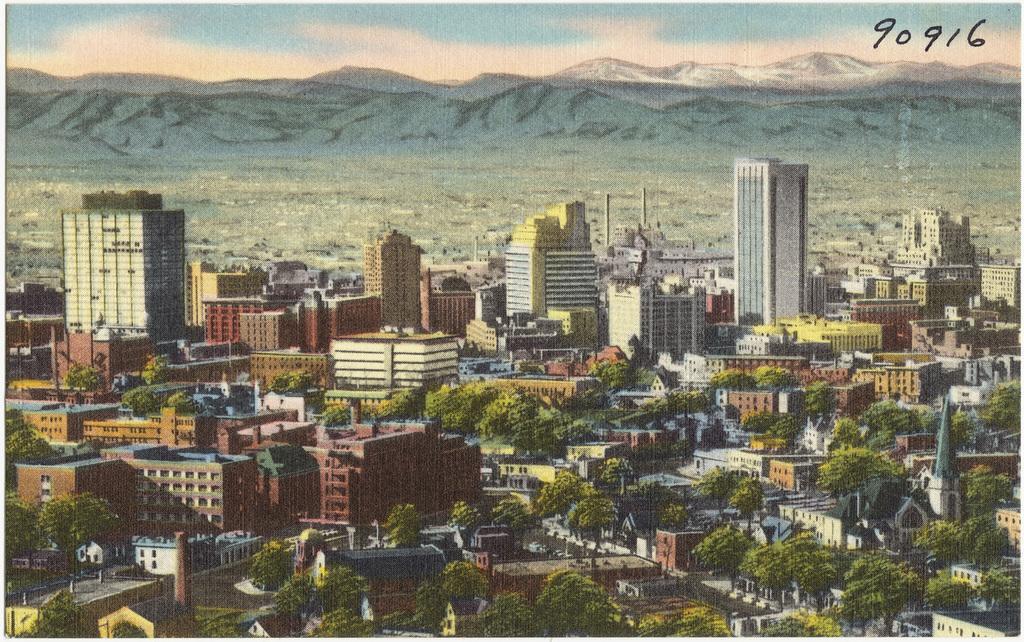Could you give a brief overview of what you see in this image? In the image we can see there are lot of buildings and trees. Behind there are mountains. 